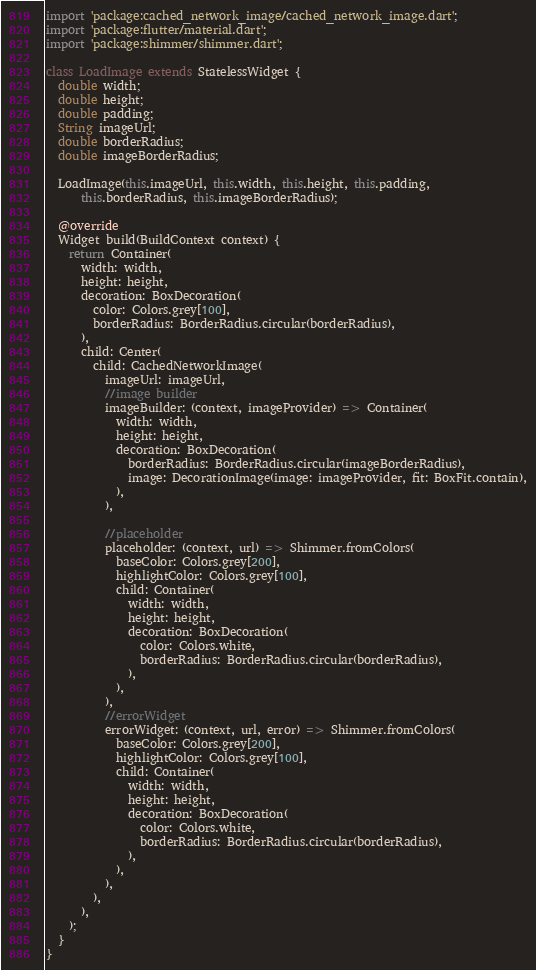<code> <loc_0><loc_0><loc_500><loc_500><_Dart_>import 'package:cached_network_image/cached_network_image.dart';
import 'package:flutter/material.dart';
import 'package:shimmer/shimmer.dart';

class LoadImage extends StatelessWidget {
  double width;
  double height;
  double padding;
  String imageUrl;
  double borderRadius;
  double imageBorderRadius;

  LoadImage(this.imageUrl, this.width, this.height, this.padding,
      this.borderRadius, this.imageBorderRadius);

  @override
  Widget build(BuildContext context) {
    return Container(
      width: width,
      height: height,
      decoration: BoxDecoration(
        color: Colors.grey[100],
        borderRadius: BorderRadius.circular(borderRadius),
      ),
      child: Center(
        child: CachedNetworkImage(
          imageUrl: imageUrl,
          //image builder
          imageBuilder: (context, imageProvider) => Container(
            width: width,
            height: height,
            decoration: BoxDecoration(
              borderRadius: BorderRadius.circular(imageBorderRadius),
              image: DecorationImage(image: imageProvider, fit: BoxFit.contain),
            ),
          ),

          //placeholder
          placeholder: (context, url) => Shimmer.fromColors(
            baseColor: Colors.grey[200],
            highlightColor: Colors.grey[100],
            child: Container(
              width: width,
              height: height,
              decoration: BoxDecoration(
                color: Colors.white,
                borderRadius: BorderRadius.circular(borderRadius),
              ),
            ),
          ),
          //errorWidget
          errorWidget: (context, url, error) => Shimmer.fromColors(
            baseColor: Colors.grey[200],
            highlightColor: Colors.grey[100],
            child: Container(
              width: width,
              height: height,
              decoration: BoxDecoration(
                color: Colors.white,
                borderRadius: BorderRadius.circular(borderRadius),
              ),
            ),
          ),
        ),
      ),
    );
  }
}</code> 